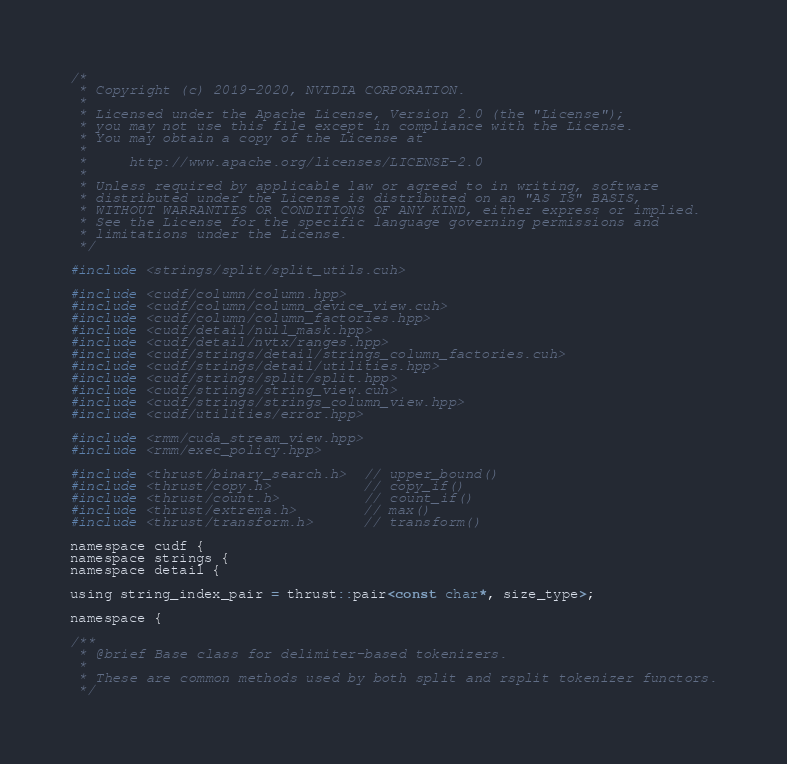Convert code to text. <code><loc_0><loc_0><loc_500><loc_500><_Cuda_>/*
 * Copyright (c) 2019-2020, NVIDIA CORPORATION.
 *
 * Licensed under the Apache License, Version 2.0 (the "License");
 * you may not use this file except in compliance with the License.
 * You may obtain a copy of the License at
 *
 *     http://www.apache.org/licenses/LICENSE-2.0
 *
 * Unless required by applicable law or agreed to in writing, software
 * distributed under the License is distributed on an "AS IS" BASIS,
 * WITHOUT WARRANTIES OR CONDITIONS OF ANY KIND, either express or implied.
 * See the License for the specific language governing permissions and
 * limitations under the License.
 */

#include <strings/split/split_utils.cuh>

#include <cudf/column/column.hpp>
#include <cudf/column/column_device_view.cuh>
#include <cudf/column/column_factories.hpp>
#include <cudf/detail/null_mask.hpp>
#include <cudf/detail/nvtx/ranges.hpp>
#include <cudf/strings/detail/strings_column_factories.cuh>
#include <cudf/strings/detail/utilities.hpp>
#include <cudf/strings/split/split.hpp>
#include <cudf/strings/string_view.cuh>
#include <cudf/strings/strings_column_view.hpp>
#include <cudf/utilities/error.hpp>

#include <rmm/cuda_stream_view.hpp>
#include <rmm/exec_policy.hpp>

#include <thrust/binary_search.h>  // upper_bound()
#include <thrust/copy.h>           // copy_if()
#include <thrust/count.h>          // count_if()
#include <thrust/extrema.h>        // max()
#include <thrust/transform.h>      // transform()

namespace cudf {
namespace strings {
namespace detail {

using string_index_pair = thrust::pair<const char*, size_type>;

namespace {

/**
 * @brief Base class for delimiter-based tokenizers.
 *
 * These are common methods used by both split and rsplit tokenizer functors.
 */</code> 